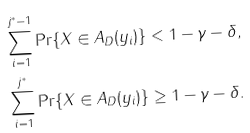Convert formula to latex. <formula><loc_0><loc_0><loc_500><loc_500>\sum _ { i = 1 } ^ { j ^ { * } - 1 } \Pr \{ X \in A _ { D } ( y _ { i } ) \} & < 1 - \gamma - \delta , \\ \sum _ { i = 1 } ^ { j ^ { * } } \Pr \{ X \in A _ { D } ( y _ { i } ) \} & \geq 1 - \gamma - \delta .</formula> 